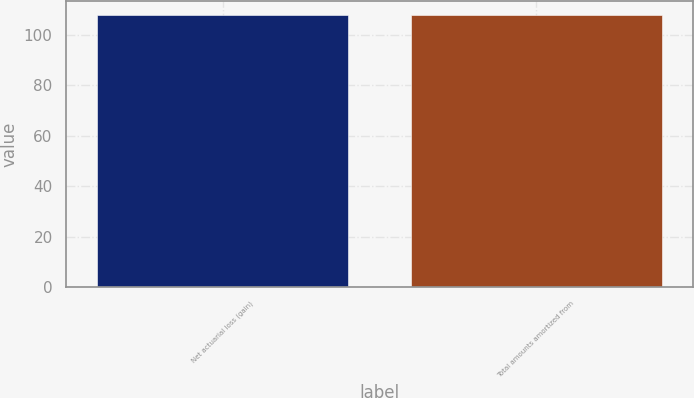Convert chart to OTSL. <chart><loc_0><loc_0><loc_500><loc_500><bar_chart><fcel>Net actuarial loss (gain)<fcel>Total amounts amortized from<nl><fcel>108<fcel>108.1<nl></chart> 